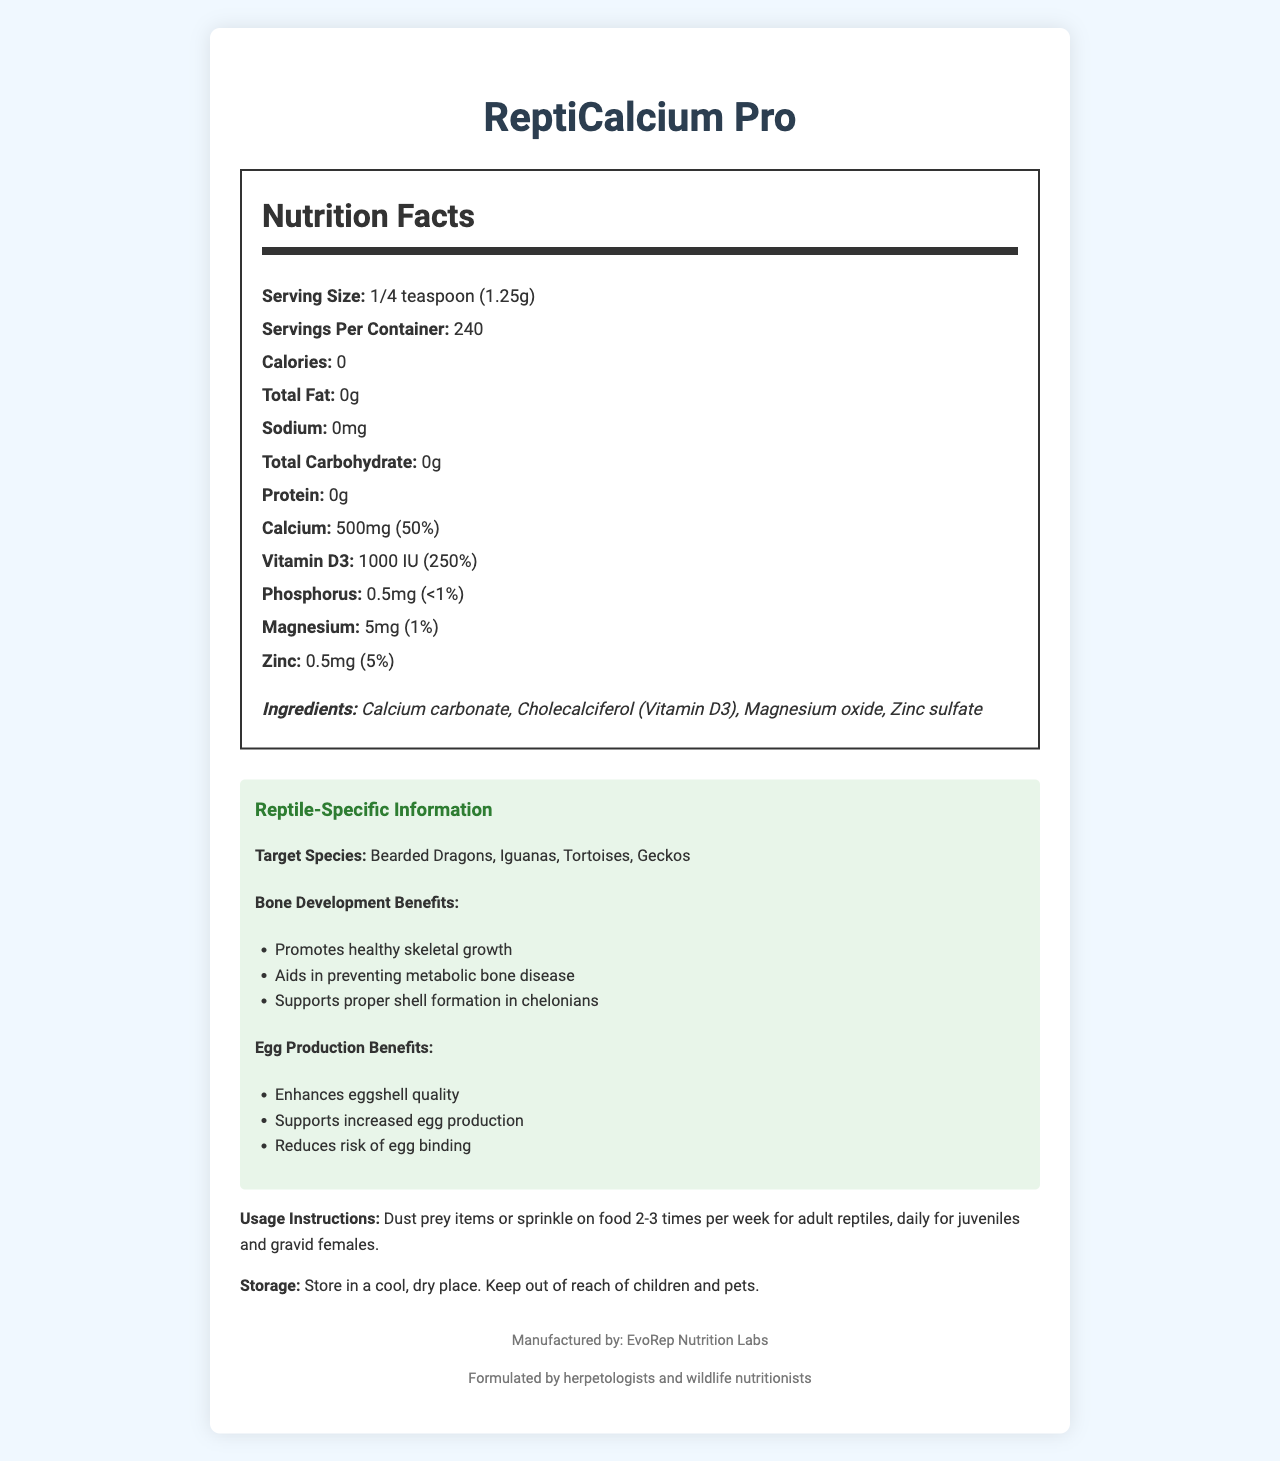what is the serving size of ReptiCalcium Pro? The serving size is clearly stated in the Nutrition Facts section of the document.
Answer: 1/4 teaspoon (1.25g) How many servings are there per container? The document specifies that there are 240 servings per container.
Answer: 240 What is the daily value percentage of calcium in ReptiCalcium Pro? The daily value percentage for calcium is shown as 50% in the Nutrition Facts section.
Answer: 50% Which vitamin in ReptiCalcium Pro has the highest daily value percentage? Vitamin D3 has a daily value percentage of 250%, which is higher than other nutrients listed.
Answer: Vitamin D3 List one benefit of ReptiCalcium Pro for bone development. The document lists several benefits for bone development, one of which is promoting healthy skeletal growth.
Answer: Promotes healthy skeletal growth Which species is NOT specifically mentioned as a target species for ReptiCalcium Pro? A. Snakes B. Bearded Dragons C. Iguanas D. Tortoises Snakes are not mentioned as a target species in the reptile-specific information section.
Answer: A What element is present in the lowest amount in ReptiCalcium Pro? A. Phosphorus B. Magnesium C. Zinc D. Calcium Phosphorus is present in the lowest amount, at 0.5mg.
Answer: A Is ReptiCalcium Pro recommended for use daily for adult reptiles? The usage instructions recommend using ReptiCalcium Pro 2-3 times per week for adult reptiles, not daily.
Answer: No Summarize the key points of the ReptiCalcium Pro document. This summary captures the product's purpose, main ingredients, benefits, target species, and usage instructions.
Answer: ReptiCalcium Pro is a specialized calcium supplement for reptiles, emphasizing its benefits for bone development and egg production. Each serving size is 1/4 teaspoon (1.25g) with 240 servings per container. It contains essential nutrients like calcium (500mg, 50% DV) and vitamin D3 (1000 IU, 250% DV). Target species include Bearded Dragons, Iguanas, Tortoises, and Geckos. The supplement promotes healthy skeletal growth and egg production, and it is recommended to be used 2-3 times per week for adults and daily for juveniles and gravid females. What is the caloric content of ReptiCalcium Pro? The Nutrition Facts section lists the caloric content as zero.
Answer: 0 calories Can the exact cost of ReptiCalcium Pro be determined from the document? The document does not provide any pricing information.
Answer: Not enough information Is ReptiCalcium Pro formulated by herpetologists and wildlife nutritionists? The footer of the document mentions that it is formulated by herpetologists and wildlife nutritionists.
Answer: Yes 